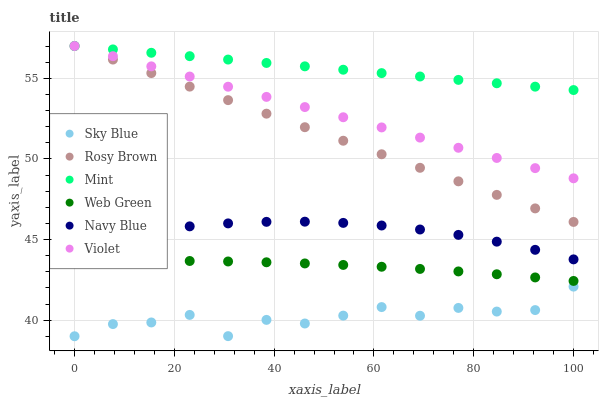Does Sky Blue have the minimum area under the curve?
Answer yes or no. Yes. Does Mint have the maximum area under the curve?
Answer yes or no. Yes. Does Rosy Brown have the minimum area under the curve?
Answer yes or no. No. Does Rosy Brown have the maximum area under the curve?
Answer yes or no. No. Is Mint the smoothest?
Answer yes or no. Yes. Is Sky Blue the roughest?
Answer yes or no. Yes. Is Rosy Brown the smoothest?
Answer yes or no. No. Is Rosy Brown the roughest?
Answer yes or no. No. Does Sky Blue have the lowest value?
Answer yes or no. Yes. Does Rosy Brown have the lowest value?
Answer yes or no. No. Does Mint have the highest value?
Answer yes or no. Yes. Does Web Green have the highest value?
Answer yes or no. No. Is Sky Blue less than Rosy Brown?
Answer yes or no. Yes. Is Violet greater than Navy Blue?
Answer yes or no. Yes. Does Rosy Brown intersect Mint?
Answer yes or no. Yes. Is Rosy Brown less than Mint?
Answer yes or no. No. Is Rosy Brown greater than Mint?
Answer yes or no. No. Does Sky Blue intersect Rosy Brown?
Answer yes or no. No. 